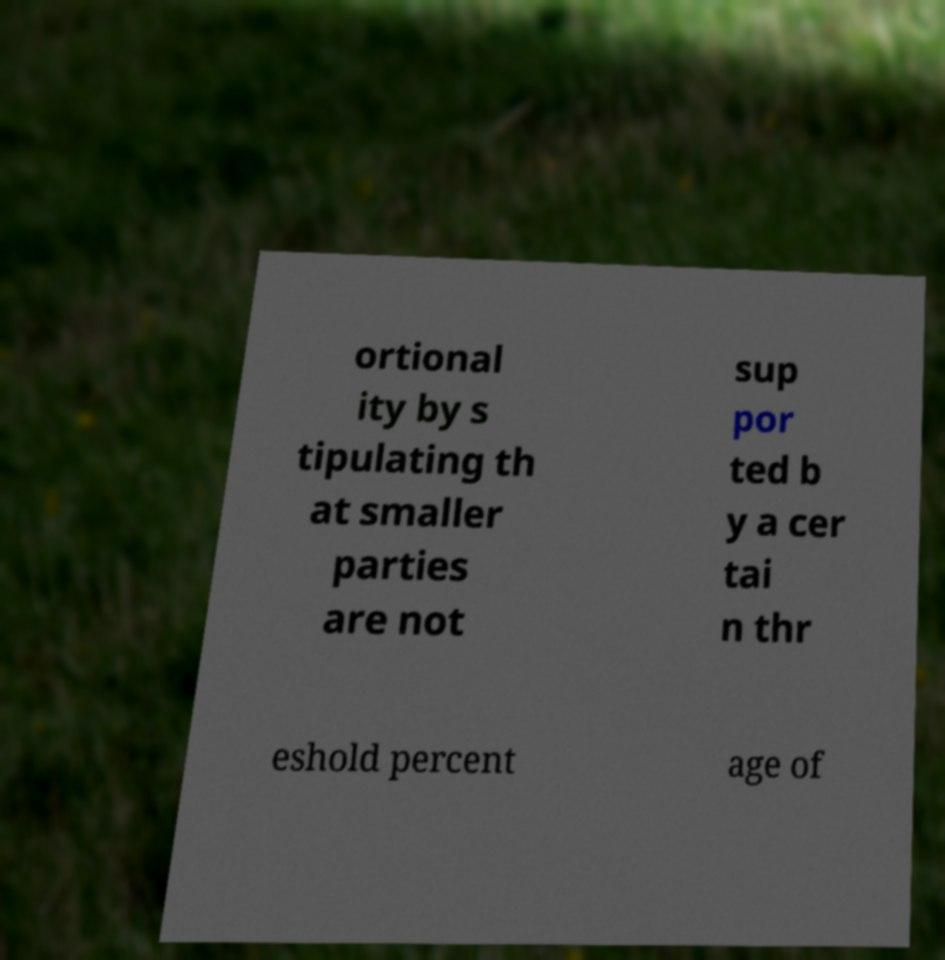Can you accurately transcribe the text from the provided image for me? ortional ity by s tipulating th at smaller parties are not sup por ted b y a cer tai n thr eshold percent age of 